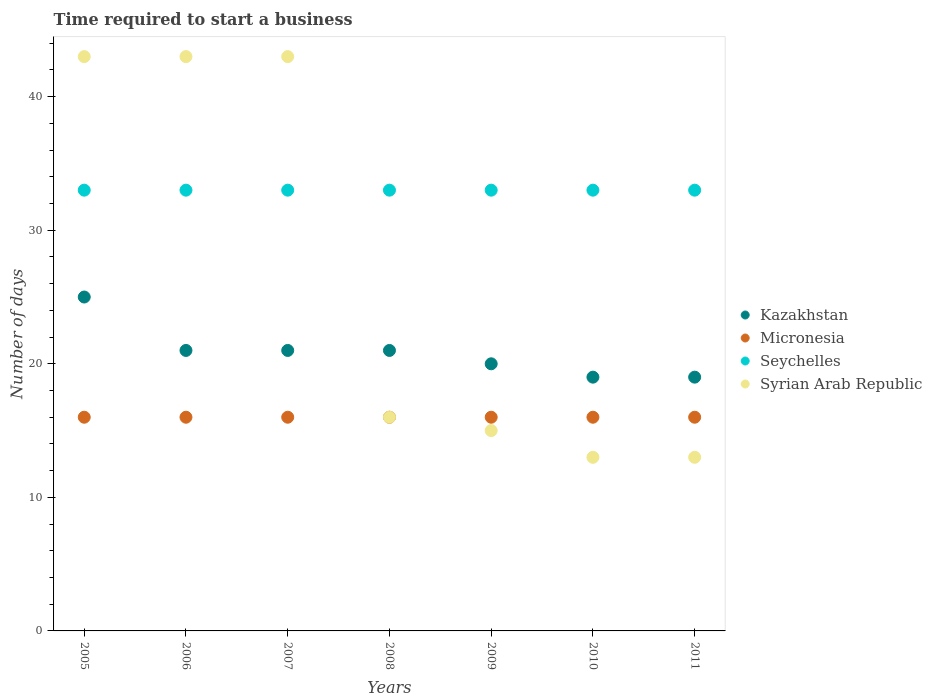Is the number of dotlines equal to the number of legend labels?
Provide a succinct answer. Yes. What is the number of days required to start a business in Kazakhstan in 2008?
Your answer should be very brief. 21. Across all years, what is the maximum number of days required to start a business in Kazakhstan?
Provide a short and direct response. 25. In which year was the number of days required to start a business in Kazakhstan maximum?
Provide a short and direct response. 2005. In which year was the number of days required to start a business in Seychelles minimum?
Give a very brief answer. 2005. What is the total number of days required to start a business in Seychelles in the graph?
Offer a very short reply. 231. What is the difference between the number of days required to start a business in Syrian Arab Republic in 2008 and that in 2010?
Offer a very short reply. 3. What is the difference between the number of days required to start a business in Seychelles in 2011 and the number of days required to start a business in Micronesia in 2010?
Offer a very short reply. 17. What is the average number of days required to start a business in Syrian Arab Republic per year?
Provide a short and direct response. 26.57. In how many years, is the number of days required to start a business in Syrian Arab Republic greater than 4 days?
Ensure brevity in your answer.  7. Is the difference between the number of days required to start a business in Syrian Arab Republic in 2008 and 2010 greater than the difference between the number of days required to start a business in Seychelles in 2008 and 2010?
Provide a succinct answer. Yes. What is the difference between the highest and the lowest number of days required to start a business in Micronesia?
Keep it short and to the point. 0. Is the sum of the number of days required to start a business in Seychelles in 2006 and 2008 greater than the maximum number of days required to start a business in Micronesia across all years?
Offer a terse response. Yes. Are the values on the major ticks of Y-axis written in scientific E-notation?
Ensure brevity in your answer.  No. Does the graph contain any zero values?
Offer a terse response. No. Does the graph contain grids?
Your answer should be compact. No. How many legend labels are there?
Offer a terse response. 4. What is the title of the graph?
Give a very brief answer. Time required to start a business. What is the label or title of the Y-axis?
Ensure brevity in your answer.  Number of days. What is the Number of days in Kazakhstan in 2005?
Provide a short and direct response. 25. What is the Number of days in Seychelles in 2005?
Your answer should be very brief. 33. What is the Number of days of Syrian Arab Republic in 2005?
Your answer should be very brief. 43. What is the Number of days of Kazakhstan in 2006?
Give a very brief answer. 21. What is the Number of days of Seychelles in 2006?
Your answer should be very brief. 33. What is the Number of days of Micronesia in 2007?
Give a very brief answer. 16. What is the Number of days in Seychelles in 2007?
Keep it short and to the point. 33. What is the Number of days of Syrian Arab Republic in 2007?
Offer a very short reply. 43. What is the Number of days in Kazakhstan in 2008?
Your answer should be compact. 21. What is the Number of days of Syrian Arab Republic in 2008?
Offer a very short reply. 16. What is the Number of days of Micronesia in 2009?
Your response must be concise. 16. What is the Number of days in Micronesia in 2010?
Offer a terse response. 16. What is the Number of days in Seychelles in 2010?
Offer a very short reply. 33. What is the Number of days in Syrian Arab Republic in 2010?
Offer a very short reply. 13. What is the Number of days in Micronesia in 2011?
Offer a very short reply. 16. What is the Number of days of Seychelles in 2011?
Make the answer very short. 33. Across all years, what is the maximum Number of days of Kazakhstan?
Offer a very short reply. 25. Across all years, what is the maximum Number of days of Seychelles?
Provide a succinct answer. 33. Across all years, what is the minimum Number of days of Micronesia?
Your answer should be compact. 16. Across all years, what is the minimum Number of days in Seychelles?
Make the answer very short. 33. Across all years, what is the minimum Number of days of Syrian Arab Republic?
Keep it short and to the point. 13. What is the total Number of days of Kazakhstan in the graph?
Make the answer very short. 146. What is the total Number of days in Micronesia in the graph?
Offer a terse response. 112. What is the total Number of days of Seychelles in the graph?
Keep it short and to the point. 231. What is the total Number of days of Syrian Arab Republic in the graph?
Your response must be concise. 186. What is the difference between the Number of days in Kazakhstan in 2005 and that in 2006?
Offer a very short reply. 4. What is the difference between the Number of days in Micronesia in 2005 and that in 2006?
Your answer should be compact. 0. What is the difference between the Number of days of Seychelles in 2005 and that in 2006?
Offer a very short reply. 0. What is the difference between the Number of days of Syrian Arab Republic in 2005 and that in 2006?
Your response must be concise. 0. What is the difference between the Number of days of Kazakhstan in 2005 and that in 2008?
Make the answer very short. 4. What is the difference between the Number of days in Syrian Arab Republic in 2005 and that in 2008?
Give a very brief answer. 27. What is the difference between the Number of days in Kazakhstan in 2005 and that in 2009?
Ensure brevity in your answer.  5. What is the difference between the Number of days of Seychelles in 2005 and that in 2009?
Your answer should be compact. 0. What is the difference between the Number of days of Micronesia in 2005 and that in 2010?
Keep it short and to the point. 0. What is the difference between the Number of days in Seychelles in 2005 and that in 2010?
Keep it short and to the point. 0. What is the difference between the Number of days of Syrian Arab Republic in 2005 and that in 2010?
Your response must be concise. 30. What is the difference between the Number of days of Kazakhstan in 2005 and that in 2011?
Provide a short and direct response. 6. What is the difference between the Number of days in Kazakhstan in 2006 and that in 2007?
Your response must be concise. 0. What is the difference between the Number of days in Seychelles in 2006 and that in 2008?
Provide a succinct answer. 0. What is the difference between the Number of days of Seychelles in 2006 and that in 2009?
Your response must be concise. 0. What is the difference between the Number of days in Syrian Arab Republic in 2006 and that in 2009?
Offer a very short reply. 28. What is the difference between the Number of days in Kazakhstan in 2006 and that in 2010?
Provide a short and direct response. 2. What is the difference between the Number of days in Seychelles in 2006 and that in 2010?
Ensure brevity in your answer.  0. What is the difference between the Number of days in Syrian Arab Republic in 2006 and that in 2010?
Offer a terse response. 30. What is the difference between the Number of days of Kazakhstan in 2006 and that in 2011?
Provide a short and direct response. 2. What is the difference between the Number of days in Micronesia in 2006 and that in 2011?
Provide a short and direct response. 0. What is the difference between the Number of days in Seychelles in 2006 and that in 2011?
Offer a very short reply. 0. What is the difference between the Number of days in Syrian Arab Republic in 2006 and that in 2011?
Give a very brief answer. 30. What is the difference between the Number of days in Micronesia in 2007 and that in 2008?
Offer a very short reply. 0. What is the difference between the Number of days of Syrian Arab Republic in 2007 and that in 2008?
Your answer should be compact. 27. What is the difference between the Number of days in Micronesia in 2007 and that in 2009?
Your answer should be compact. 0. What is the difference between the Number of days in Seychelles in 2007 and that in 2009?
Offer a very short reply. 0. What is the difference between the Number of days of Syrian Arab Republic in 2007 and that in 2009?
Offer a terse response. 28. What is the difference between the Number of days in Kazakhstan in 2007 and that in 2010?
Provide a short and direct response. 2. What is the difference between the Number of days of Micronesia in 2007 and that in 2010?
Your answer should be compact. 0. What is the difference between the Number of days in Syrian Arab Republic in 2007 and that in 2010?
Offer a terse response. 30. What is the difference between the Number of days of Micronesia in 2007 and that in 2011?
Ensure brevity in your answer.  0. What is the difference between the Number of days in Micronesia in 2008 and that in 2009?
Make the answer very short. 0. What is the difference between the Number of days of Seychelles in 2008 and that in 2009?
Your response must be concise. 0. What is the difference between the Number of days of Syrian Arab Republic in 2008 and that in 2009?
Keep it short and to the point. 1. What is the difference between the Number of days of Kazakhstan in 2008 and that in 2011?
Ensure brevity in your answer.  2. What is the difference between the Number of days in Micronesia in 2008 and that in 2011?
Keep it short and to the point. 0. What is the difference between the Number of days in Syrian Arab Republic in 2008 and that in 2011?
Ensure brevity in your answer.  3. What is the difference between the Number of days of Kazakhstan in 2009 and that in 2010?
Provide a succinct answer. 1. What is the difference between the Number of days of Seychelles in 2009 and that in 2010?
Your answer should be compact. 0. What is the difference between the Number of days in Syrian Arab Republic in 2009 and that in 2010?
Offer a very short reply. 2. What is the difference between the Number of days in Kazakhstan in 2009 and that in 2011?
Your response must be concise. 1. What is the difference between the Number of days of Micronesia in 2009 and that in 2011?
Offer a very short reply. 0. What is the difference between the Number of days in Seychelles in 2009 and that in 2011?
Provide a short and direct response. 0. What is the difference between the Number of days of Syrian Arab Republic in 2009 and that in 2011?
Provide a succinct answer. 2. What is the difference between the Number of days of Seychelles in 2010 and that in 2011?
Provide a short and direct response. 0. What is the difference between the Number of days in Syrian Arab Republic in 2010 and that in 2011?
Offer a very short reply. 0. What is the difference between the Number of days in Kazakhstan in 2005 and the Number of days in Seychelles in 2006?
Keep it short and to the point. -8. What is the difference between the Number of days of Kazakhstan in 2005 and the Number of days of Syrian Arab Republic in 2006?
Provide a succinct answer. -18. What is the difference between the Number of days of Micronesia in 2005 and the Number of days of Seychelles in 2006?
Your answer should be compact. -17. What is the difference between the Number of days in Seychelles in 2005 and the Number of days in Syrian Arab Republic in 2006?
Your answer should be compact. -10. What is the difference between the Number of days of Kazakhstan in 2005 and the Number of days of Micronesia in 2007?
Your answer should be very brief. 9. What is the difference between the Number of days of Micronesia in 2005 and the Number of days of Seychelles in 2007?
Make the answer very short. -17. What is the difference between the Number of days in Kazakhstan in 2005 and the Number of days in Micronesia in 2008?
Your answer should be compact. 9. What is the difference between the Number of days in Kazakhstan in 2005 and the Number of days in Syrian Arab Republic in 2008?
Your answer should be compact. 9. What is the difference between the Number of days in Micronesia in 2005 and the Number of days in Seychelles in 2008?
Make the answer very short. -17. What is the difference between the Number of days of Micronesia in 2005 and the Number of days of Syrian Arab Republic in 2008?
Offer a terse response. 0. What is the difference between the Number of days in Seychelles in 2005 and the Number of days in Syrian Arab Republic in 2008?
Provide a short and direct response. 17. What is the difference between the Number of days of Kazakhstan in 2005 and the Number of days of Micronesia in 2009?
Provide a succinct answer. 9. What is the difference between the Number of days of Kazakhstan in 2005 and the Number of days of Micronesia in 2010?
Ensure brevity in your answer.  9. What is the difference between the Number of days in Kazakhstan in 2005 and the Number of days in Syrian Arab Republic in 2010?
Provide a short and direct response. 12. What is the difference between the Number of days in Kazakhstan in 2005 and the Number of days in Syrian Arab Republic in 2011?
Make the answer very short. 12. What is the difference between the Number of days of Kazakhstan in 2006 and the Number of days of Syrian Arab Republic in 2007?
Offer a terse response. -22. What is the difference between the Number of days of Micronesia in 2006 and the Number of days of Syrian Arab Republic in 2007?
Offer a terse response. -27. What is the difference between the Number of days in Kazakhstan in 2006 and the Number of days in Micronesia in 2008?
Offer a terse response. 5. What is the difference between the Number of days in Kazakhstan in 2006 and the Number of days in Seychelles in 2008?
Make the answer very short. -12. What is the difference between the Number of days in Seychelles in 2006 and the Number of days in Syrian Arab Republic in 2008?
Provide a short and direct response. 17. What is the difference between the Number of days in Kazakhstan in 2006 and the Number of days in Micronesia in 2009?
Make the answer very short. 5. What is the difference between the Number of days in Micronesia in 2006 and the Number of days in Seychelles in 2009?
Ensure brevity in your answer.  -17. What is the difference between the Number of days in Micronesia in 2006 and the Number of days in Syrian Arab Republic in 2009?
Keep it short and to the point. 1. What is the difference between the Number of days of Kazakhstan in 2006 and the Number of days of Seychelles in 2010?
Your response must be concise. -12. What is the difference between the Number of days in Kazakhstan in 2006 and the Number of days in Syrian Arab Republic in 2010?
Your answer should be compact. 8. What is the difference between the Number of days in Micronesia in 2006 and the Number of days in Seychelles in 2010?
Provide a succinct answer. -17. What is the difference between the Number of days in Micronesia in 2006 and the Number of days in Syrian Arab Republic in 2010?
Your response must be concise. 3. What is the difference between the Number of days of Kazakhstan in 2006 and the Number of days of Micronesia in 2011?
Give a very brief answer. 5. What is the difference between the Number of days in Kazakhstan in 2006 and the Number of days in Seychelles in 2011?
Offer a terse response. -12. What is the difference between the Number of days in Micronesia in 2006 and the Number of days in Seychelles in 2011?
Provide a succinct answer. -17. What is the difference between the Number of days in Micronesia in 2007 and the Number of days in Syrian Arab Republic in 2008?
Give a very brief answer. 0. What is the difference between the Number of days in Kazakhstan in 2007 and the Number of days in Micronesia in 2009?
Keep it short and to the point. 5. What is the difference between the Number of days in Kazakhstan in 2007 and the Number of days in Seychelles in 2009?
Offer a very short reply. -12. What is the difference between the Number of days in Kazakhstan in 2007 and the Number of days in Syrian Arab Republic in 2009?
Provide a succinct answer. 6. What is the difference between the Number of days in Micronesia in 2007 and the Number of days in Seychelles in 2009?
Your response must be concise. -17. What is the difference between the Number of days in Kazakhstan in 2007 and the Number of days in Micronesia in 2010?
Provide a short and direct response. 5. What is the difference between the Number of days in Kazakhstan in 2007 and the Number of days in Syrian Arab Republic in 2010?
Give a very brief answer. 8. What is the difference between the Number of days in Micronesia in 2007 and the Number of days in Seychelles in 2010?
Offer a very short reply. -17. What is the difference between the Number of days in Micronesia in 2007 and the Number of days in Syrian Arab Republic in 2010?
Offer a terse response. 3. What is the difference between the Number of days of Kazakhstan in 2007 and the Number of days of Seychelles in 2011?
Make the answer very short. -12. What is the difference between the Number of days in Kazakhstan in 2007 and the Number of days in Syrian Arab Republic in 2011?
Your answer should be very brief. 8. What is the difference between the Number of days in Seychelles in 2007 and the Number of days in Syrian Arab Republic in 2011?
Provide a short and direct response. 20. What is the difference between the Number of days in Kazakhstan in 2008 and the Number of days in Micronesia in 2009?
Your response must be concise. 5. What is the difference between the Number of days in Kazakhstan in 2008 and the Number of days in Seychelles in 2009?
Your answer should be very brief. -12. What is the difference between the Number of days in Micronesia in 2008 and the Number of days in Seychelles in 2009?
Your answer should be very brief. -17. What is the difference between the Number of days of Micronesia in 2008 and the Number of days of Syrian Arab Republic in 2009?
Your response must be concise. 1. What is the difference between the Number of days in Kazakhstan in 2008 and the Number of days in Micronesia in 2010?
Keep it short and to the point. 5. What is the difference between the Number of days in Kazakhstan in 2008 and the Number of days in Seychelles in 2010?
Your response must be concise. -12. What is the difference between the Number of days in Kazakhstan in 2008 and the Number of days in Syrian Arab Republic in 2010?
Provide a short and direct response. 8. What is the difference between the Number of days in Micronesia in 2008 and the Number of days in Syrian Arab Republic in 2010?
Your answer should be compact. 3. What is the difference between the Number of days of Seychelles in 2008 and the Number of days of Syrian Arab Republic in 2010?
Keep it short and to the point. 20. What is the difference between the Number of days in Kazakhstan in 2008 and the Number of days in Micronesia in 2011?
Give a very brief answer. 5. What is the difference between the Number of days in Kazakhstan in 2008 and the Number of days in Seychelles in 2011?
Ensure brevity in your answer.  -12. What is the difference between the Number of days in Micronesia in 2008 and the Number of days in Seychelles in 2011?
Provide a short and direct response. -17. What is the difference between the Number of days in Kazakhstan in 2009 and the Number of days in Syrian Arab Republic in 2010?
Your answer should be very brief. 7. What is the difference between the Number of days in Micronesia in 2009 and the Number of days in Seychelles in 2010?
Offer a terse response. -17. What is the difference between the Number of days in Seychelles in 2009 and the Number of days in Syrian Arab Republic in 2010?
Your answer should be very brief. 20. What is the difference between the Number of days of Kazakhstan in 2009 and the Number of days of Micronesia in 2011?
Offer a very short reply. 4. What is the difference between the Number of days of Micronesia in 2010 and the Number of days of Seychelles in 2011?
Your response must be concise. -17. What is the difference between the Number of days of Micronesia in 2010 and the Number of days of Syrian Arab Republic in 2011?
Give a very brief answer. 3. What is the average Number of days of Kazakhstan per year?
Offer a very short reply. 20.86. What is the average Number of days in Syrian Arab Republic per year?
Offer a very short reply. 26.57. In the year 2005, what is the difference between the Number of days of Kazakhstan and Number of days of Micronesia?
Make the answer very short. 9. In the year 2005, what is the difference between the Number of days in Kazakhstan and Number of days in Seychelles?
Offer a very short reply. -8. In the year 2005, what is the difference between the Number of days of Micronesia and Number of days of Seychelles?
Keep it short and to the point. -17. In the year 2005, what is the difference between the Number of days in Micronesia and Number of days in Syrian Arab Republic?
Give a very brief answer. -27. In the year 2006, what is the difference between the Number of days in Kazakhstan and Number of days in Syrian Arab Republic?
Your response must be concise. -22. In the year 2006, what is the difference between the Number of days of Micronesia and Number of days of Seychelles?
Give a very brief answer. -17. In the year 2006, what is the difference between the Number of days in Seychelles and Number of days in Syrian Arab Republic?
Ensure brevity in your answer.  -10. In the year 2007, what is the difference between the Number of days in Kazakhstan and Number of days in Micronesia?
Keep it short and to the point. 5. In the year 2008, what is the difference between the Number of days in Kazakhstan and Number of days in Micronesia?
Ensure brevity in your answer.  5. In the year 2008, what is the difference between the Number of days in Micronesia and Number of days in Syrian Arab Republic?
Provide a short and direct response. 0. In the year 2009, what is the difference between the Number of days of Kazakhstan and Number of days of Seychelles?
Offer a very short reply. -13. In the year 2009, what is the difference between the Number of days of Kazakhstan and Number of days of Syrian Arab Republic?
Provide a succinct answer. 5. In the year 2009, what is the difference between the Number of days in Micronesia and Number of days in Seychelles?
Offer a very short reply. -17. In the year 2010, what is the difference between the Number of days of Kazakhstan and Number of days of Seychelles?
Provide a succinct answer. -14. In the year 2010, what is the difference between the Number of days of Micronesia and Number of days of Seychelles?
Your answer should be compact. -17. In the year 2011, what is the difference between the Number of days of Kazakhstan and Number of days of Micronesia?
Make the answer very short. 3. In the year 2011, what is the difference between the Number of days of Kazakhstan and Number of days of Seychelles?
Ensure brevity in your answer.  -14. In the year 2011, what is the difference between the Number of days of Kazakhstan and Number of days of Syrian Arab Republic?
Make the answer very short. 6. In the year 2011, what is the difference between the Number of days in Micronesia and Number of days in Seychelles?
Make the answer very short. -17. What is the ratio of the Number of days in Kazakhstan in 2005 to that in 2006?
Keep it short and to the point. 1.19. What is the ratio of the Number of days in Micronesia in 2005 to that in 2006?
Your answer should be very brief. 1. What is the ratio of the Number of days of Seychelles in 2005 to that in 2006?
Provide a short and direct response. 1. What is the ratio of the Number of days of Kazakhstan in 2005 to that in 2007?
Your answer should be compact. 1.19. What is the ratio of the Number of days in Micronesia in 2005 to that in 2007?
Ensure brevity in your answer.  1. What is the ratio of the Number of days in Kazakhstan in 2005 to that in 2008?
Your response must be concise. 1.19. What is the ratio of the Number of days in Micronesia in 2005 to that in 2008?
Your answer should be compact. 1. What is the ratio of the Number of days of Seychelles in 2005 to that in 2008?
Your response must be concise. 1. What is the ratio of the Number of days of Syrian Arab Republic in 2005 to that in 2008?
Make the answer very short. 2.69. What is the ratio of the Number of days of Kazakhstan in 2005 to that in 2009?
Keep it short and to the point. 1.25. What is the ratio of the Number of days in Syrian Arab Republic in 2005 to that in 2009?
Ensure brevity in your answer.  2.87. What is the ratio of the Number of days in Kazakhstan in 2005 to that in 2010?
Your response must be concise. 1.32. What is the ratio of the Number of days of Seychelles in 2005 to that in 2010?
Ensure brevity in your answer.  1. What is the ratio of the Number of days in Syrian Arab Republic in 2005 to that in 2010?
Make the answer very short. 3.31. What is the ratio of the Number of days in Kazakhstan in 2005 to that in 2011?
Your response must be concise. 1.32. What is the ratio of the Number of days of Seychelles in 2005 to that in 2011?
Make the answer very short. 1. What is the ratio of the Number of days of Syrian Arab Republic in 2005 to that in 2011?
Your answer should be compact. 3.31. What is the ratio of the Number of days in Kazakhstan in 2006 to that in 2007?
Ensure brevity in your answer.  1. What is the ratio of the Number of days in Micronesia in 2006 to that in 2007?
Ensure brevity in your answer.  1. What is the ratio of the Number of days in Micronesia in 2006 to that in 2008?
Ensure brevity in your answer.  1. What is the ratio of the Number of days of Seychelles in 2006 to that in 2008?
Your answer should be compact. 1. What is the ratio of the Number of days of Syrian Arab Republic in 2006 to that in 2008?
Provide a succinct answer. 2.69. What is the ratio of the Number of days of Seychelles in 2006 to that in 2009?
Offer a very short reply. 1. What is the ratio of the Number of days of Syrian Arab Republic in 2006 to that in 2009?
Your response must be concise. 2.87. What is the ratio of the Number of days of Kazakhstan in 2006 to that in 2010?
Provide a short and direct response. 1.11. What is the ratio of the Number of days of Micronesia in 2006 to that in 2010?
Keep it short and to the point. 1. What is the ratio of the Number of days in Syrian Arab Republic in 2006 to that in 2010?
Your response must be concise. 3.31. What is the ratio of the Number of days of Kazakhstan in 2006 to that in 2011?
Provide a short and direct response. 1.11. What is the ratio of the Number of days of Syrian Arab Republic in 2006 to that in 2011?
Ensure brevity in your answer.  3.31. What is the ratio of the Number of days in Micronesia in 2007 to that in 2008?
Provide a short and direct response. 1. What is the ratio of the Number of days of Syrian Arab Republic in 2007 to that in 2008?
Make the answer very short. 2.69. What is the ratio of the Number of days of Kazakhstan in 2007 to that in 2009?
Give a very brief answer. 1.05. What is the ratio of the Number of days in Micronesia in 2007 to that in 2009?
Offer a terse response. 1. What is the ratio of the Number of days of Seychelles in 2007 to that in 2009?
Offer a very short reply. 1. What is the ratio of the Number of days of Syrian Arab Republic in 2007 to that in 2009?
Provide a short and direct response. 2.87. What is the ratio of the Number of days of Kazakhstan in 2007 to that in 2010?
Make the answer very short. 1.11. What is the ratio of the Number of days of Seychelles in 2007 to that in 2010?
Keep it short and to the point. 1. What is the ratio of the Number of days in Syrian Arab Republic in 2007 to that in 2010?
Keep it short and to the point. 3.31. What is the ratio of the Number of days in Kazakhstan in 2007 to that in 2011?
Make the answer very short. 1.11. What is the ratio of the Number of days of Syrian Arab Republic in 2007 to that in 2011?
Keep it short and to the point. 3.31. What is the ratio of the Number of days in Seychelles in 2008 to that in 2009?
Provide a succinct answer. 1. What is the ratio of the Number of days in Syrian Arab Republic in 2008 to that in 2009?
Provide a short and direct response. 1.07. What is the ratio of the Number of days in Kazakhstan in 2008 to that in 2010?
Provide a short and direct response. 1.11. What is the ratio of the Number of days of Micronesia in 2008 to that in 2010?
Your answer should be very brief. 1. What is the ratio of the Number of days of Seychelles in 2008 to that in 2010?
Your response must be concise. 1. What is the ratio of the Number of days of Syrian Arab Republic in 2008 to that in 2010?
Provide a short and direct response. 1.23. What is the ratio of the Number of days in Kazakhstan in 2008 to that in 2011?
Make the answer very short. 1.11. What is the ratio of the Number of days in Seychelles in 2008 to that in 2011?
Provide a short and direct response. 1. What is the ratio of the Number of days of Syrian Arab Republic in 2008 to that in 2011?
Offer a very short reply. 1.23. What is the ratio of the Number of days in Kazakhstan in 2009 to that in 2010?
Offer a terse response. 1.05. What is the ratio of the Number of days in Micronesia in 2009 to that in 2010?
Offer a very short reply. 1. What is the ratio of the Number of days in Seychelles in 2009 to that in 2010?
Your answer should be very brief. 1. What is the ratio of the Number of days in Syrian Arab Republic in 2009 to that in 2010?
Provide a succinct answer. 1.15. What is the ratio of the Number of days of Kazakhstan in 2009 to that in 2011?
Offer a terse response. 1.05. What is the ratio of the Number of days of Syrian Arab Republic in 2009 to that in 2011?
Offer a very short reply. 1.15. What is the ratio of the Number of days of Micronesia in 2010 to that in 2011?
Offer a terse response. 1. What is the ratio of the Number of days in Seychelles in 2010 to that in 2011?
Make the answer very short. 1. What is the difference between the highest and the second highest Number of days in Seychelles?
Keep it short and to the point. 0. What is the difference between the highest and the lowest Number of days of Kazakhstan?
Keep it short and to the point. 6. 